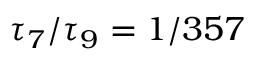<formula> <loc_0><loc_0><loc_500><loc_500>\tau _ { 7 } / \tau _ { 9 } = 1 / 3 5 7</formula> 